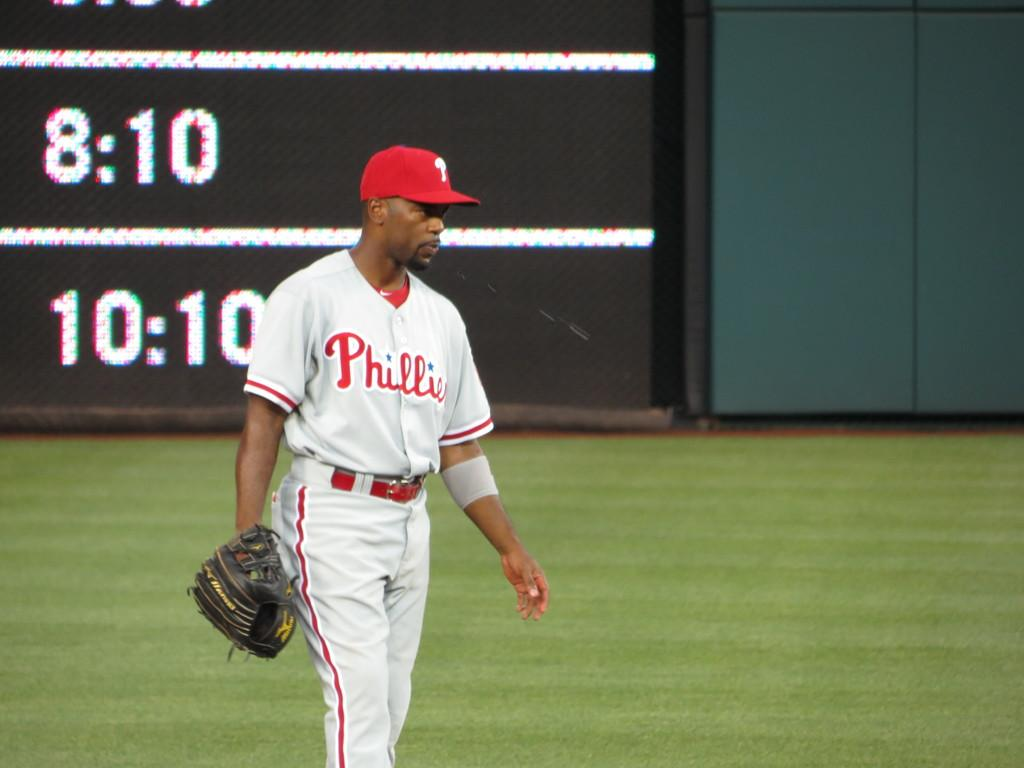<image>
Share a concise interpretation of the image provided. A baseball player in a Phillies jersey holds his glove in the outfield. 